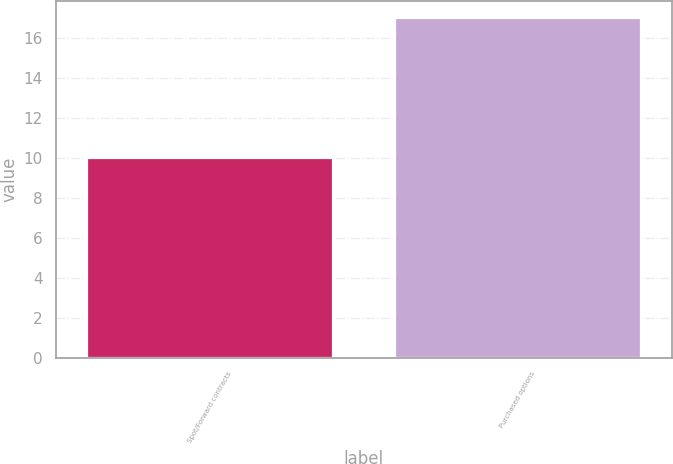Convert chart to OTSL. <chart><loc_0><loc_0><loc_500><loc_500><bar_chart><fcel>Spot/Forward contracts<fcel>Purchased options<nl><fcel>10<fcel>17<nl></chart> 